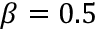Convert formula to latex. <formula><loc_0><loc_0><loc_500><loc_500>\beta = 0 . 5</formula> 